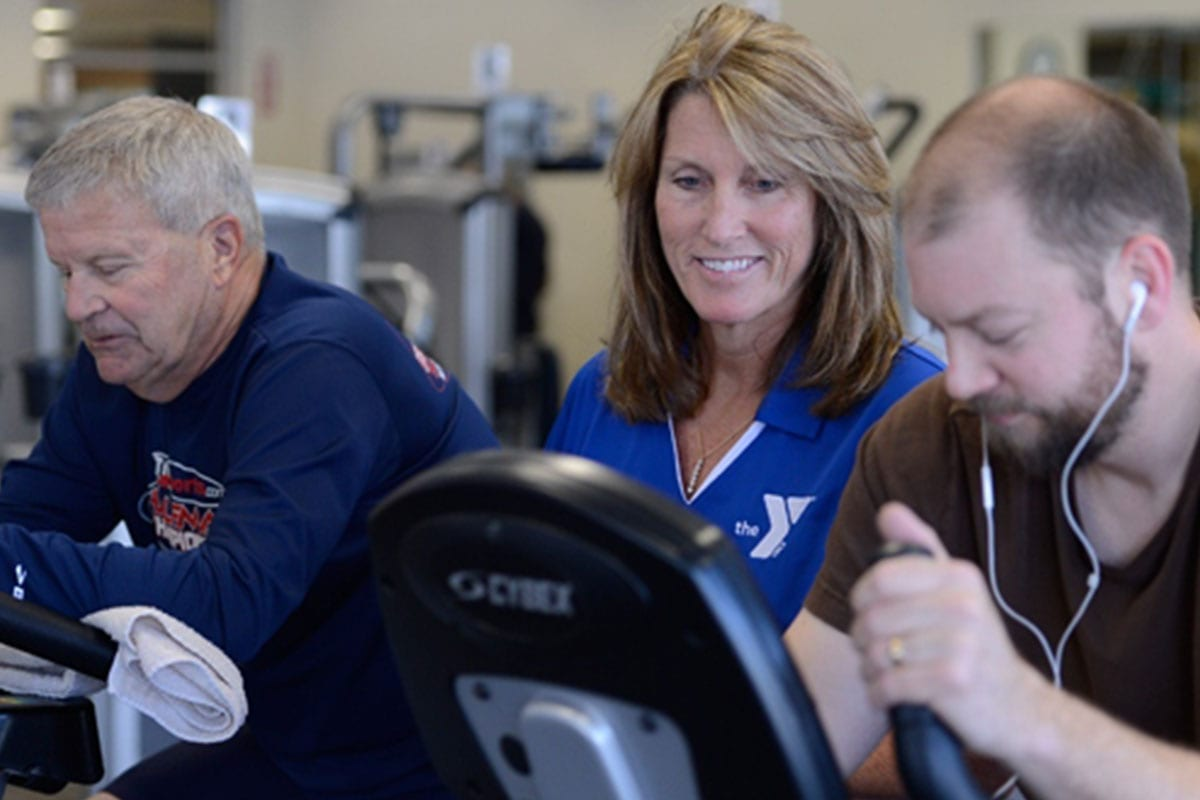What unique or niche fitness trends could the instructor incorporate to keep the workouts exciting and engaging? The instructor could incorporate unique or niche fitness trends such as 'virtual reality workouts,' where participants use VR headsets to immerse themselves in different environments while exercising. She might also introduce 'animal flow,' a workout style inspired by animal movements that improve strength, flexibility, and coordination. Another engaging trend could be 'fitness scavenger hunts,' where participants collect clues or complete challenges around the gym. Additionally, 'gamification' of workouts, where exercises are structured as games with levels, rewards, and leaderboards, can provide a fun and motivating way to keep participants engaged. These trends not only add variety but also make the fitness experience enjoyable and innovative.  If the instructor were to host a motivational workshop, what key topics should she cover to inspire and educate the participants? In a motivational workshop, the instructor should cover key topics such as setting realistic and achievable fitness goals, understanding the benefits of regular exercise for physical and mental health, and tips for maintaining long-term motivation. She could also discuss the importance of nutrition and hydration in achieving fitness goals, and ways to overcome common obstacles and setbacks in a workout routine. Additionally, incorporating success stories and personal experiences can provide relatable and inspiring examples for participants. Practical advice on how to integrate fitness into a busy lifestyle and the significance of rest and recovery would also be valuable topics. Interactive elements such as group discussions, Q&A sessions, and practical demonstrations can make the workshop more engaging and impactful. 